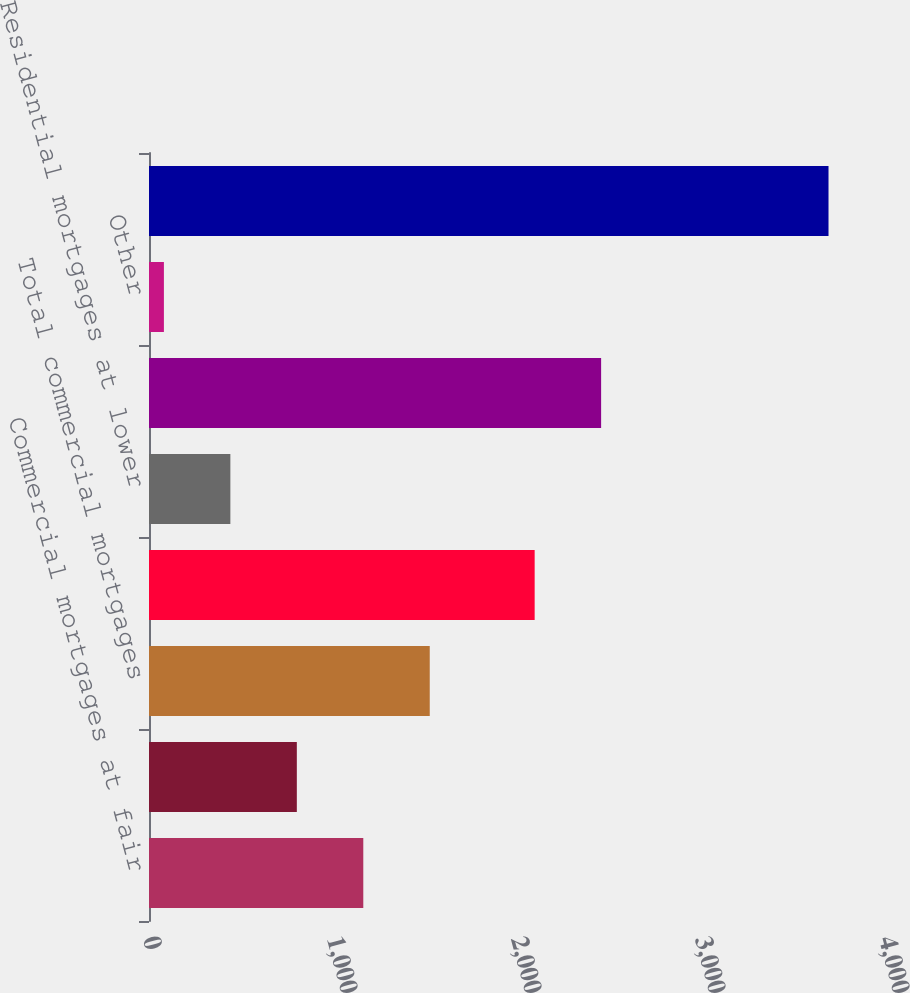Convert chart to OTSL. <chart><loc_0><loc_0><loc_500><loc_500><bar_chart><fcel>Commercial mortgages at fair<fcel>Commercial mortgages at lower<fcel>Total commercial mortgages<fcel>Residential mortgages at fair<fcel>Residential mortgages at lower<fcel>Total residential mortgages<fcel>Other<fcel>Total<nl><fcel>1164.6<fcel>803.4<fcel>1525.8<fcel>2096<fcel>442.2<fcel>2457.2<fcel>81<fcel>3693<nl></chart> 